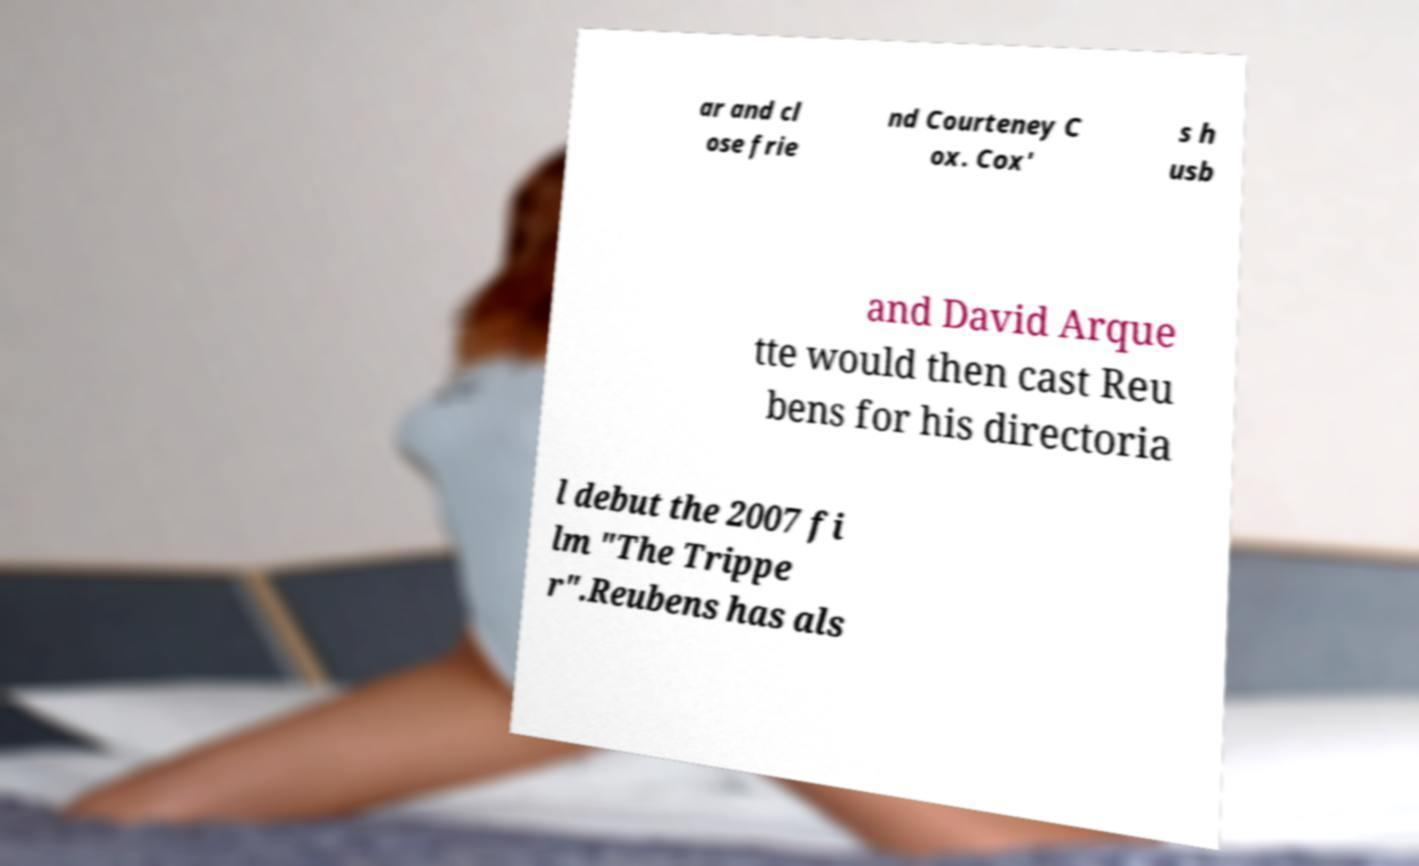Please identify and transcribe the text found in this image. ar and cl ose frie nd Courteney C ox. Cox' s h usb and David Arque tte would then cast Reu bens for his directoria l debut the 2007 fi lm "The Trippe r".Reubens has als 